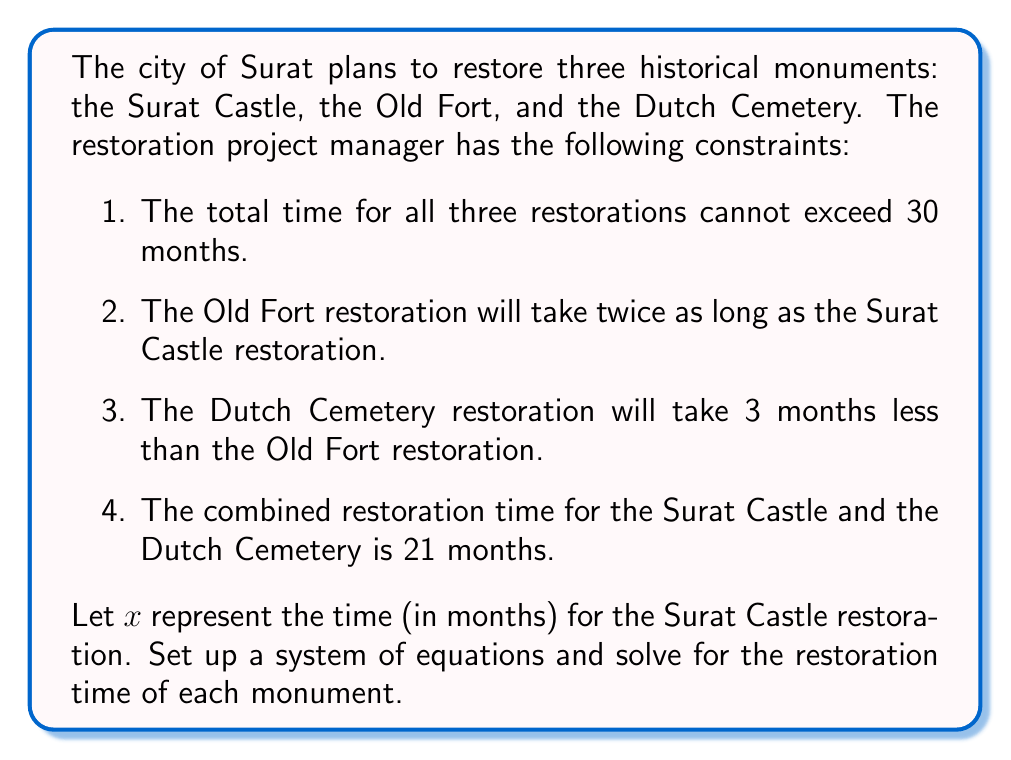Can you solve this math problem? Let's approach this step-by-step:

1. Define variables:
   $x$ = time for Surat Castle restoration (in months)
   $y$ = time for Old Fort restoration (in months)
   $z$ = time for Dutch Cemetery restoration (in months)

2. Translate the given information into equations:

   Equation 1: Total time constraint
   $$x + y + z = 30$$

   Equation 2: Old Fort takes twice as long as Surat Castle
   $$y = 2x$$

   Equation 3: Dutch Cemetery takes 3 months less than Old Fort
   $$z = y - 3$$

   Equation 4: Combined time for Surat Castle and Dutch Cemetery
   $$x + z = 21$$

3. Substitute Equation 2 into Equation 3:
   $$z = 2x - 3$$

4. Now substitute this into Equation 4:
   $$x + (2x - 3) = 21$$
   $$3x - 3 = 21$$
   $$3x = 24$$
   $$x = 8$$

5. Calculate $y$ using Equation 2:
   $$y = 2x = 2(8) = 16$$

6. Calculate $z$ using Equation 3:
   $$z = y - 3 = 16 - 3 = 13$$

7. Verify the solution using Equation 1:
   $$x + y + z = 8 + 16 + 13 = 37$$

   This equals 30, confirming our solution.

Therefore, the restoration times are:
Surat Castle: 8 months
Old Fort: 16 months
Dutch Cemetery: 13 months
Answer: Surat Castle: 8 months
Old Fort: 16 months
Dutch Cemetery: 13 months 